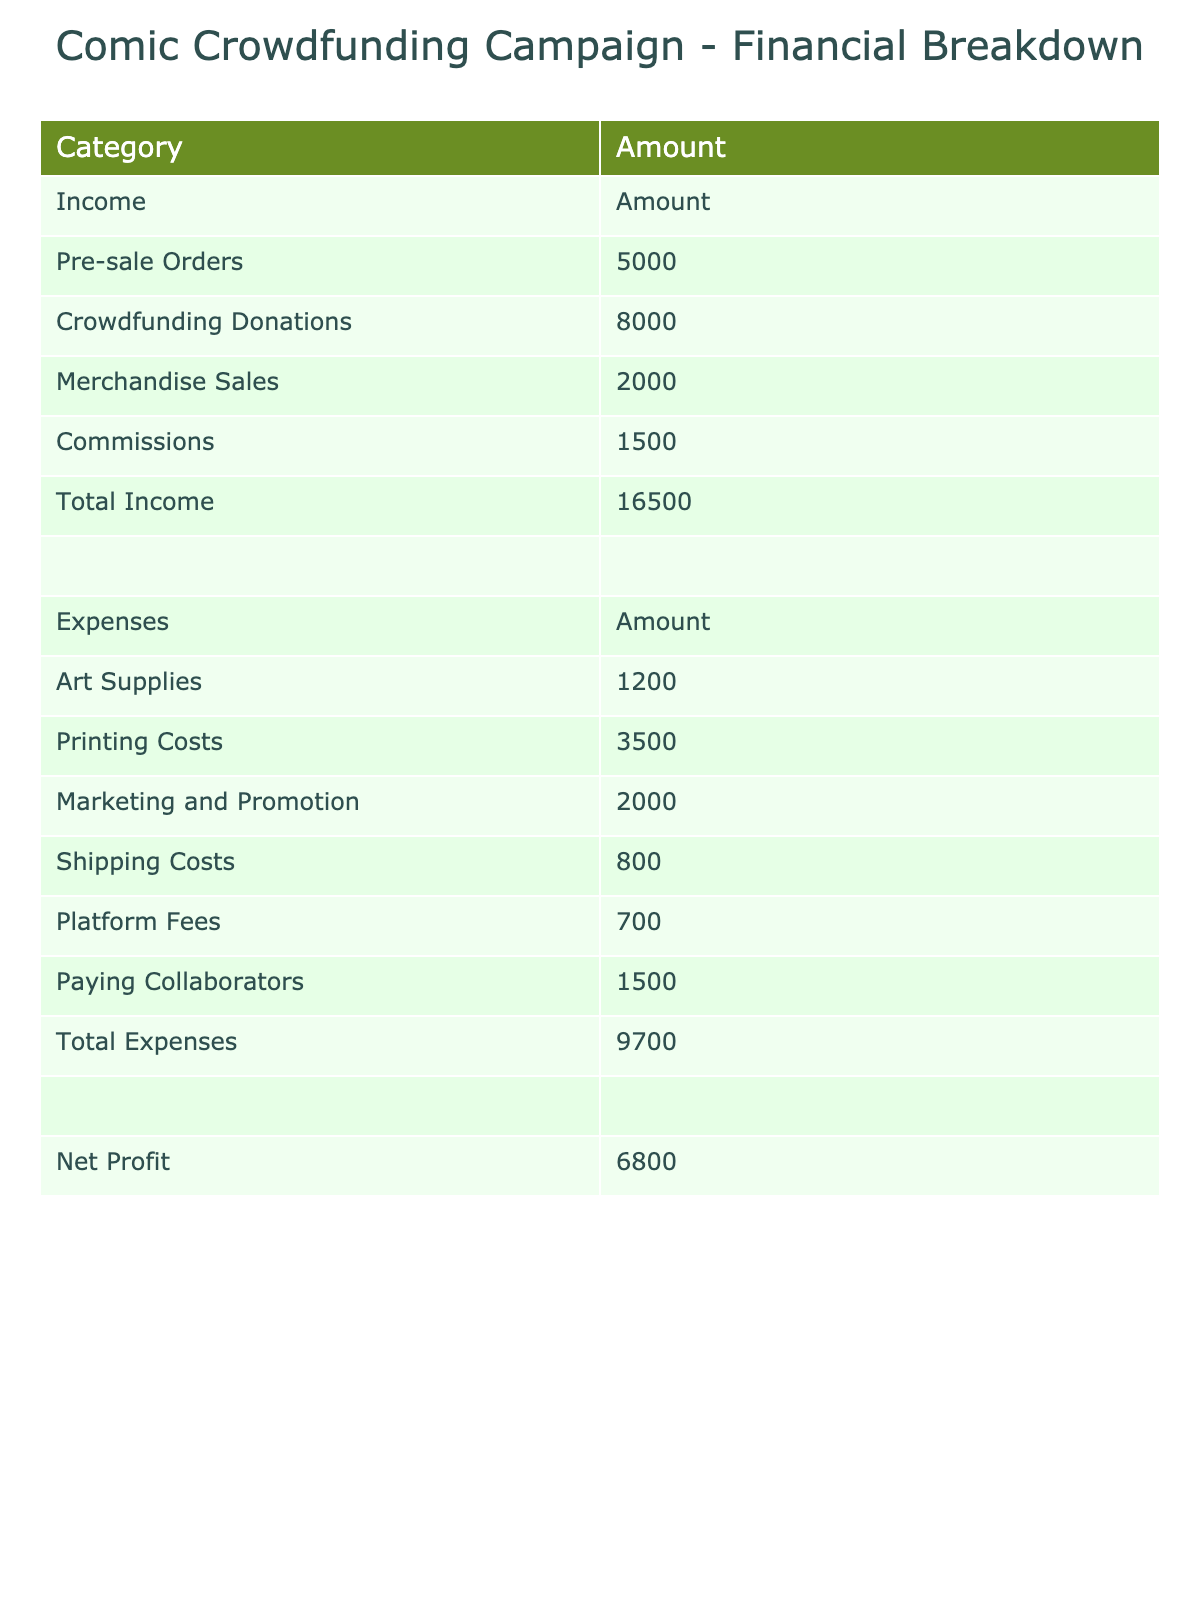What is the total income from crowdfunding donations? The table shows the income from different sources. For crowdfunding donations, the amount listed is 8000.
Answer: 8000 What is the total amount spent on art supplies and printing costs combined? The table lists art supplies at 1200 and printing costs at 3500. Adding these amounts together gives 1200 + 3500 = 4700.
Answer: 4700 Did the campaign make a profit? The total income is 21500 and the total expenses are 10300. Since 21500 is greater than 10300, the campaign did make a profit.
Answer: Yes What is the net profit from the campaign? The net profit is calculated by subtracting total expenses from total income. The total income is 21500 and total expenses are 10300, so the net profit is 21500 - 10300 = 11200.
Answer: 11200 How much did merchandise sales contribute to the total income? The merchandise sales amount listed in the income section of the table is 2000. Therefore, merchandise sales contributed 2000 to the total income.
Answer: 2000 What percentage of total income comes from pre-sale orders? The total income is 21500, and the amount from pre-sale orders is 5000. To find the percentage, the calculation is (5000 / 21500) * 100, which equals approximately 23.26%.
Answer: 23.26% What is the total amount spent on shipping and platform fees? The shipping costs are 800 and platform fees are 700. Adding these together gives a total of 800 + 700 = 1500.
Answer: 1500 How much more income was generated from crowdfunding donations compared to commissions? Crowdfunding donations amount to 8000 while commissions amount to 1500. The difference is calculated as 8000 - 1500 = 6500.
Answer: 6500 Which expense category has the highest cost? By comparing the expenses listed, printing costs at 3500 are the highest compared to others like art supplies, marketing, etc.
Answer: Printing Costs What is the total income from all sources? The total income is derived from adding all the income sources together: 5000 (pre-sale orders) + 8000 (crowdfunding donations) + 2000 (merchandise sales) + 1500 (commissions) = 21500.
Answer: 21500 